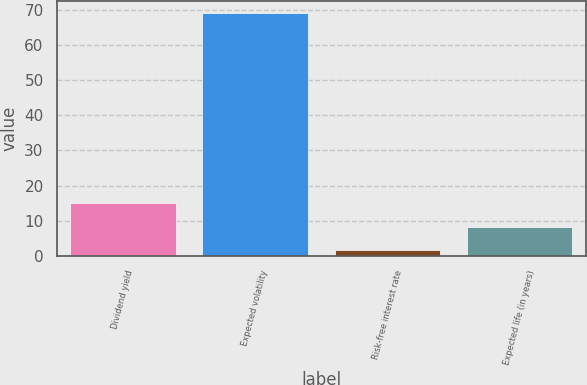<chart> <loc_0><loc_0><loc_500><loc_500><bar_chart><fcel>Dividend yield<fcel>Expected volatility<fcel>Risk-free interest rate<fcel>Expected life (in years)<nl><fcel>15.07<fcel>69<fcel>1.59<fcel>8.33<nl></chart> 